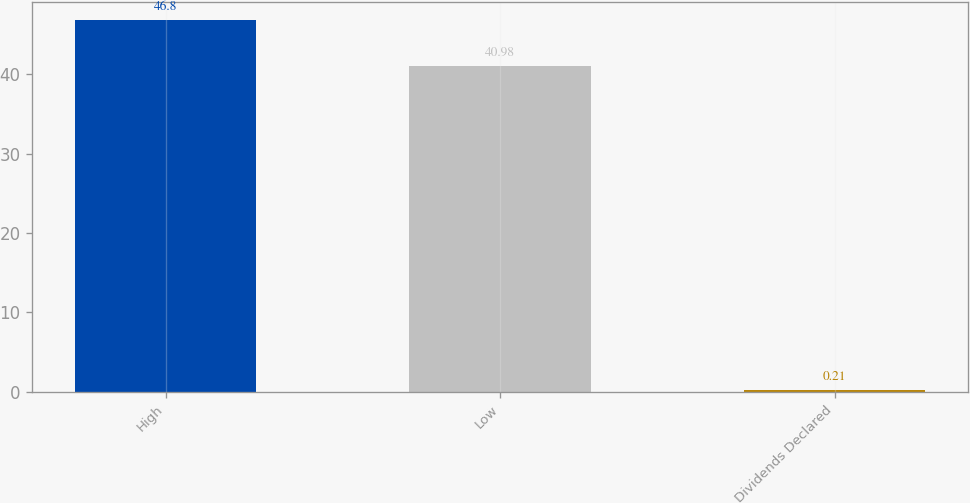Convert chart to OTSL. <chart><loc_0><loc_0><loc_500><loc_500><bar_chart><fcel>High<fcel>Low<fcel>Dividends Declared<nl><fcel>46.8<fcel>40.98<fcel>0.21<nl></chart> 